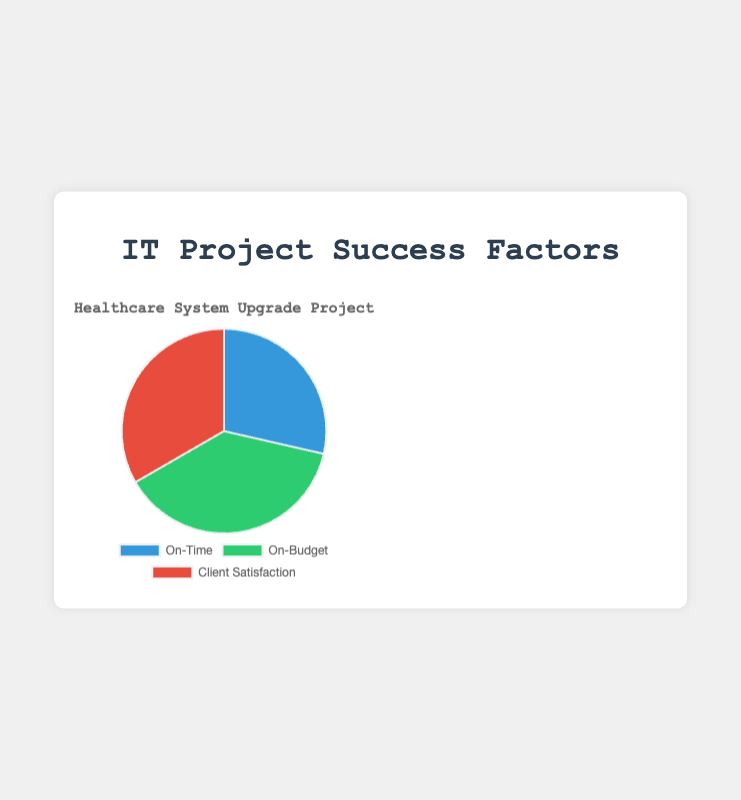Which factor has the highest value in the pie chart? By looking at the sections of the pie chart, the green-colored section representing "On-Budget" is the largest. Therefore, "On-Budget" has the highest value.
Answer: On-Budget Which factor has the smallest value in the pie chart? Observing the pie chart, the smallest section is the blue-colored section representing "On-Time."
Answer: On-Time What is the difference between the values of "On-Budget" and "Client Satisfaction"? The values for "On-Budget" and "Client Satisfaction" are 40 and 35, respectively. The difference is calculated as 40 - 35 = 5.
Answer: 5 What is the average value for the three factors shown in the pie chart? Summing the values of the three factors gives 30 (On-Time) + 40 (On-Budget) + 35 (Client Satisfaction) = 105. Dividing by the number of factors, 105 / 3 = 35.
Answer: 35 Which two factors have the same value for any specific project, according to the dataset used for the pie chart? For the "BankingAppDevelopment" project, both "On-Time" and "On-Budget" have a value of 25.
Answer: On-Time and On-Budget If "Client Satisfaction" increased by 10 units and "On-Time" decreased by 5 units, which factor would have the largest value? Increasing "Client Satisfaction" by 10 units gives it a new value of 45. Decreasing "On-Time" by 5 units gives it a new value of 25. The values then would be 25, 40, and 45 for "On-Time," "On-Budget," and "Client Satisfaction," respectively. Therefore, "Client Satisfaction" would have the largest value.
Answer: Client Satisfaction How does the value of "On-Budget" compare to the combined value of "On-Time" and "Client Satisfaction"? Adding the values of "On-Time" and "Client Satisfaction" gives 30 + 35 = 65, which is greater than the value of "On-Budget" (40).
Answer: Less than What color represents the "Client Satisfaction" in the pie chart? Referring to the visual attributes of the pie chart, "Client Satisfaction" is represented by the red-colored section.
Answer: Red What is the sum of the values of "On-Time" and "On-Budget" for the "HealthcareSystemUpgrade" project? The values for "On-Time" and "On-Budget" are 30 and 40, respectively. The sum is 30 + 40 = 70.
Answer: 70 If you were to double the "On-Time" value, what would its value be? The current value of "On-Time" is 30. Doubling it gives 30 * 2 = 60.
Answer: 60 